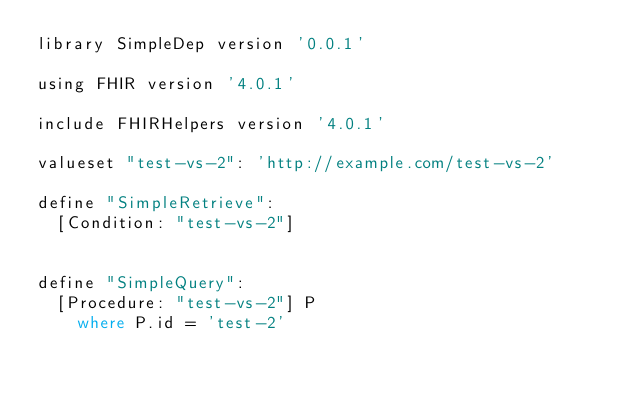<code> <loc_0><loc_0><loc_500><loc_500><_SQL_>library SimpleDep version '0.0.1'

using FHIR version '4.0.1'

include FHIRHelpers version '4.0.1'

valueset "test-vs-2": 'http://example.com/test-vs-2'

define "SimpleRetrieve":
  [Condition: "test-vs-2"]


define "SimpleQuery":
  [Procedure: "test-vs-2"] P
    where P.id = 'test-2' 

</code> 